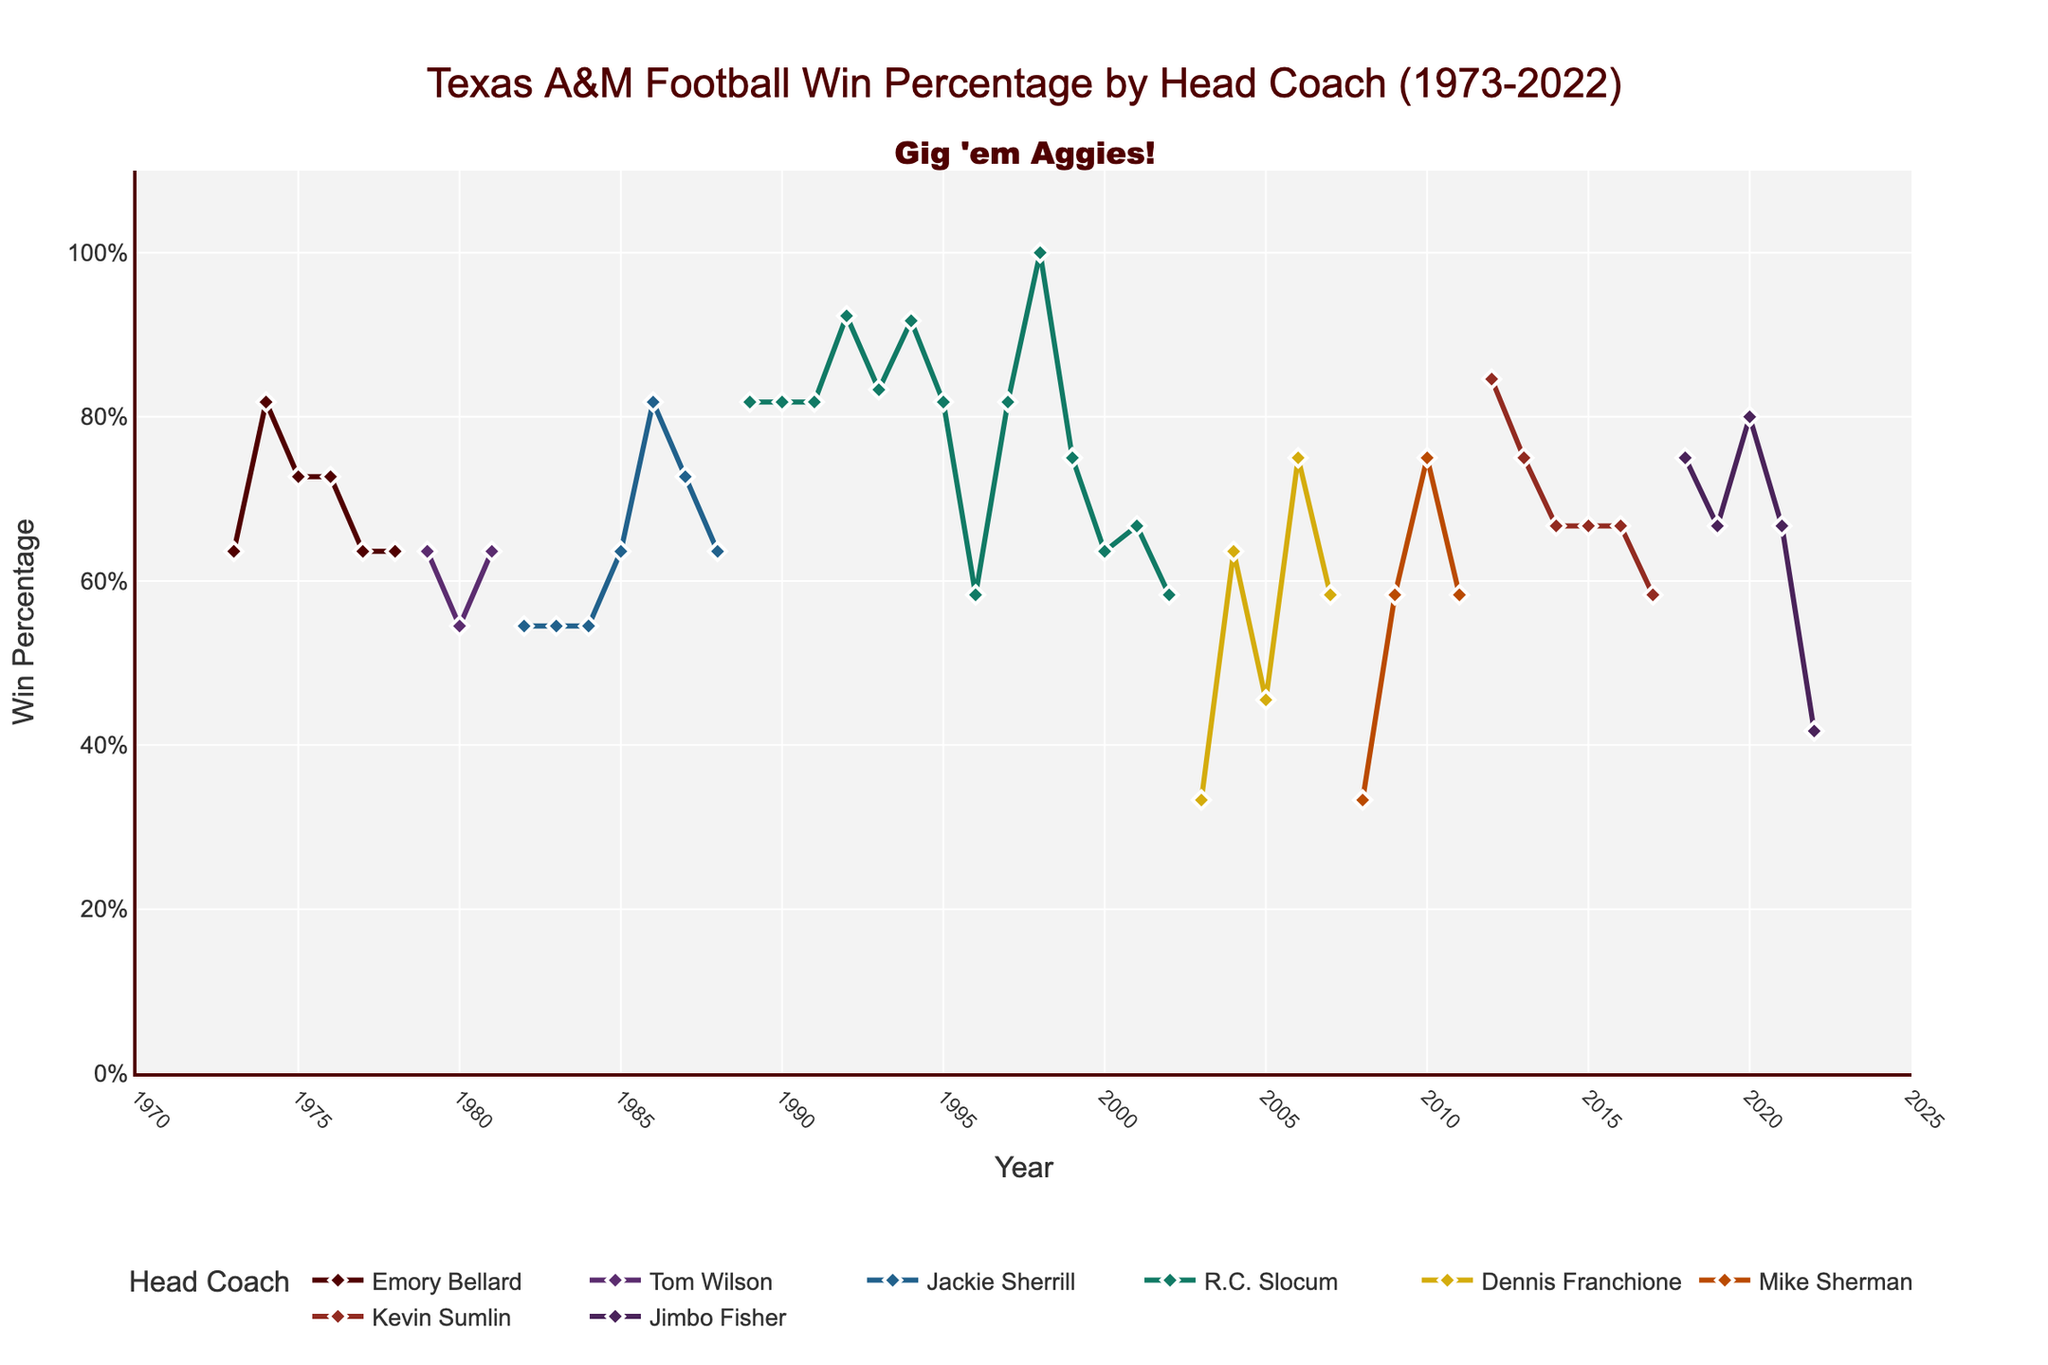What's the win percentage for Texas A&M in 1998? Look at the figure and locate the point corresponding to the year 1998. Check the y-axis value of the point associated with R.C. Slocum.
Answer: 1.000 Between which years did R.C. Slocum achieve a high win percentage of at least 0.800 repeatedly? Identify the year range where R.C. Slocum maintained a win percentage of 0.800 or higher. Check for continuous years with these values.
Answer: 1989-1991 Whose tenure shows the lowest win percentage, and what is that percentage? Examine the series of win percentages for each coach. Identify the coach with the minimum win percentage value.
Answer: Dennis Franchione, 0.333 Which coach's tenure begins with the lowest win percentage? Look at the starting year for each coach and check their first year's win percentage. Identify the lowest.
Answer: Dennis Franchione Compare Kevin Sumlin's and Jimbo Fisher's tenure. Who had a year with the highest win percentage and what was it? Evaluate the win percentages during the tenures of Kevin Sumlin and Jimbo Fisher. Identify the highest value and the corresponding coach.
Answer: Jimbo Fisher, 0.846 During which year did Texas A&M achieve the highest win percentage and under which coach? Identify the peak win percentage point on the chart and refer to the year and coach associated with that point.
Answer: 1998, R.C. Slocum What was the average win percentage during Emory Bellard's tenure? Sum the win percentages of Emory Bellard and divide by the number of years he coached. The years are 1973-1978. Calculation: (0.636 + 0.818 + 0.727 + 0.727 + 0.636 + 0.636) / 6 = 0.697
Answer: 0.697 How did the win percentage trend change from Tom Wilson to Jackie Sherrill? Compare Tom Wilson's final year percentage in 1981 with Jackie Sherrill's initial years (1982, 1983). Observe any trends. Wilson ended at 0.636, Sherrill started at 0.545. Thus, there is a decline.
Answer: Declined Assess the performance trend under Dennis Franchione. Did the win percentage improve or decline over his tenure? Analyze the win percentages from 2003 to 2007 under Dennis Franchione. Note whether there is an upward or downward trend overall.
Answer: Mixed What visual indicator shows the change of coaches on the graph? Identify the visual representation used to mark changes of head coaches, such as shifts in line color.
Answer: Change in line color 